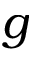<formula> <loc_0><loc_0><loc_500><loc_500>g</formula> 